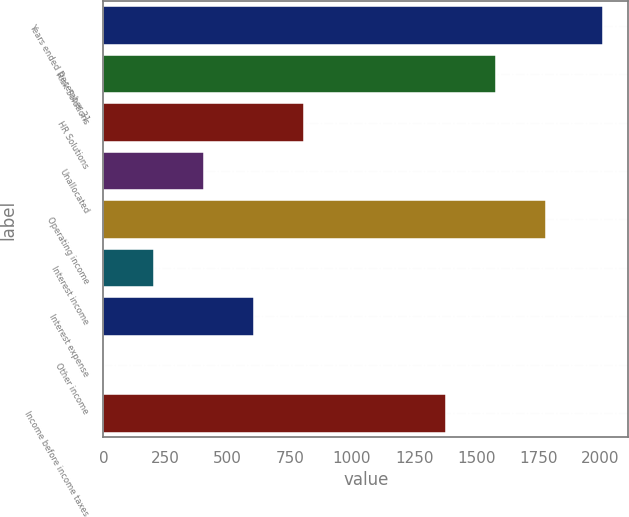Convert chart. <chart><loc_0><loc_0><loc_500><loc_500><bar_chart><fcel>Years ended December 31<fcel>Risk Solutions<fcel>HR Solutions<fcel>Unallocated<fcel>Operating income<fcel>Interest income<fcel>Interest expense<fcel>Other income<fcel>Income before income taxes<nl><fcel>2012<fcel>1581<fcel>806<fcel>404<fcel>1782<fcel>203<fcel>605<fcel>2<fcel>1380<nl></chart> 